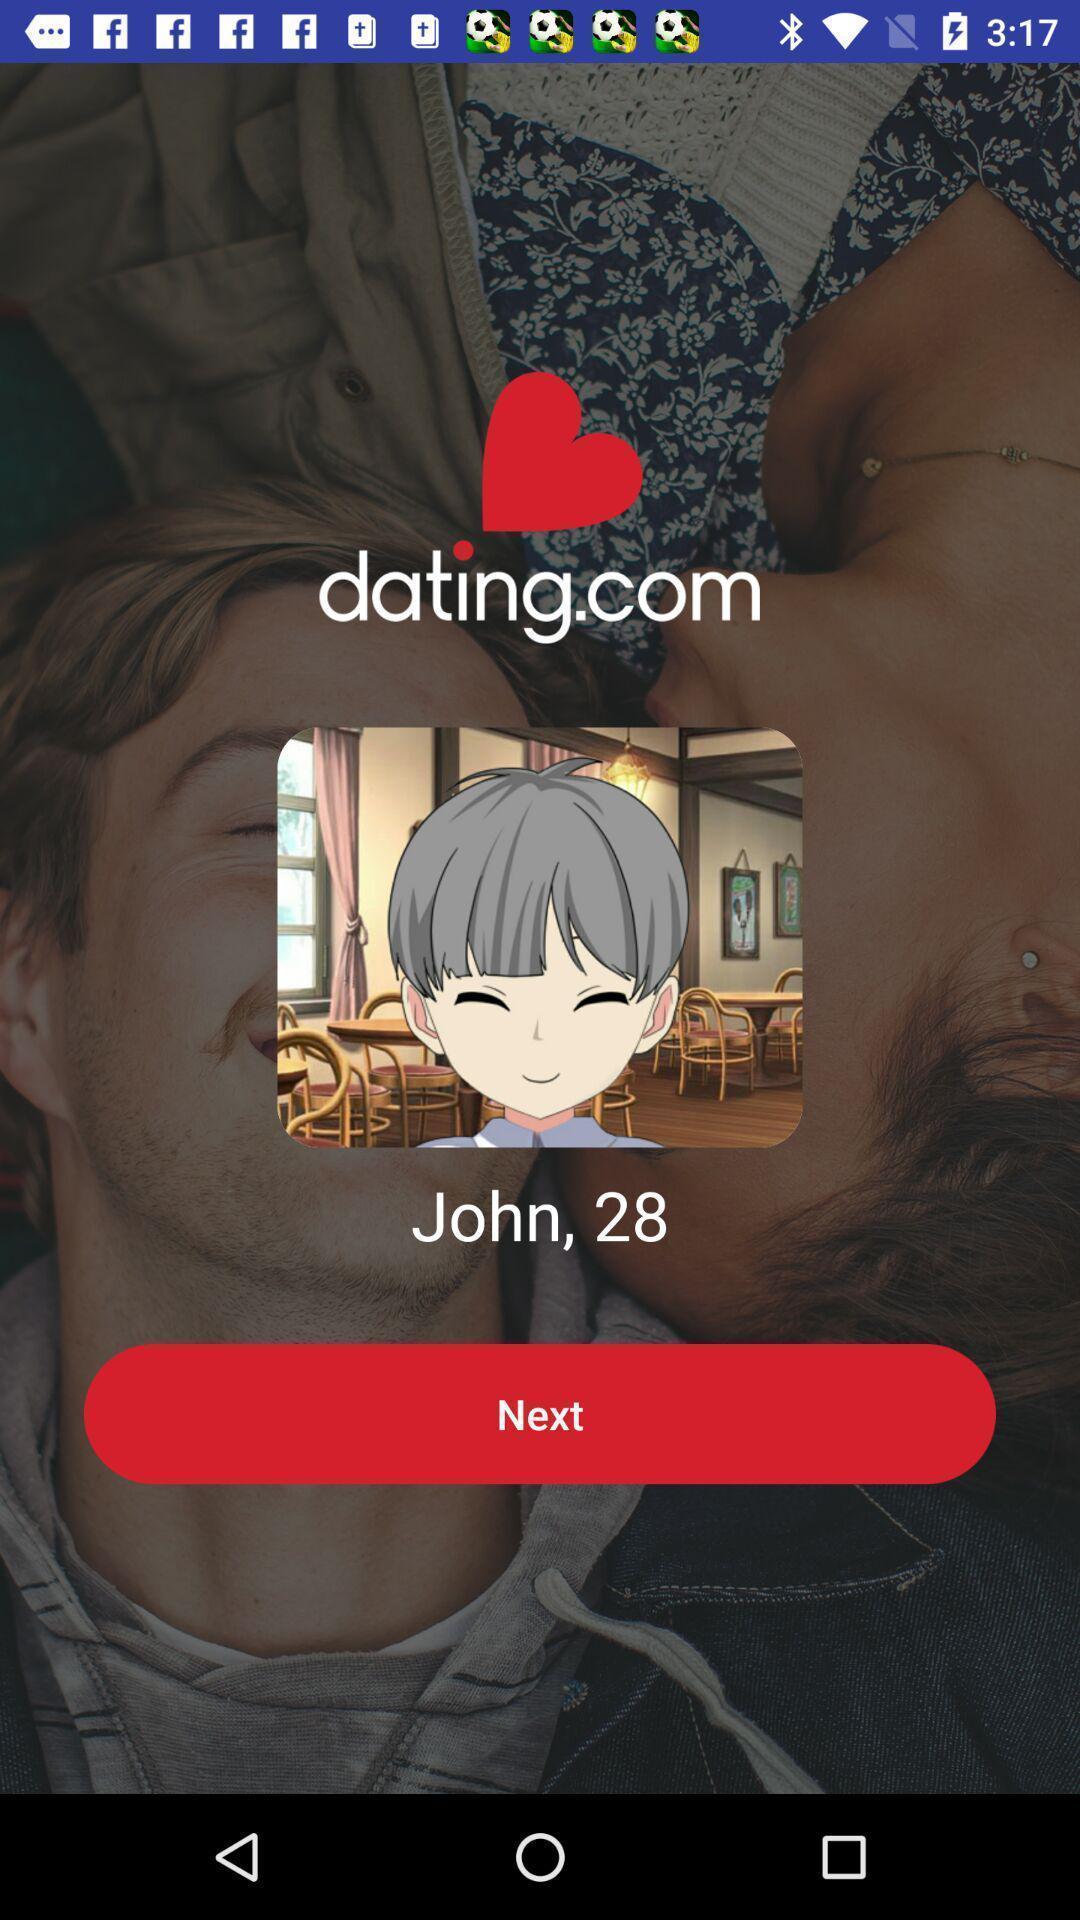Describe the visual elements of this screenshot. Start page of a social app. 